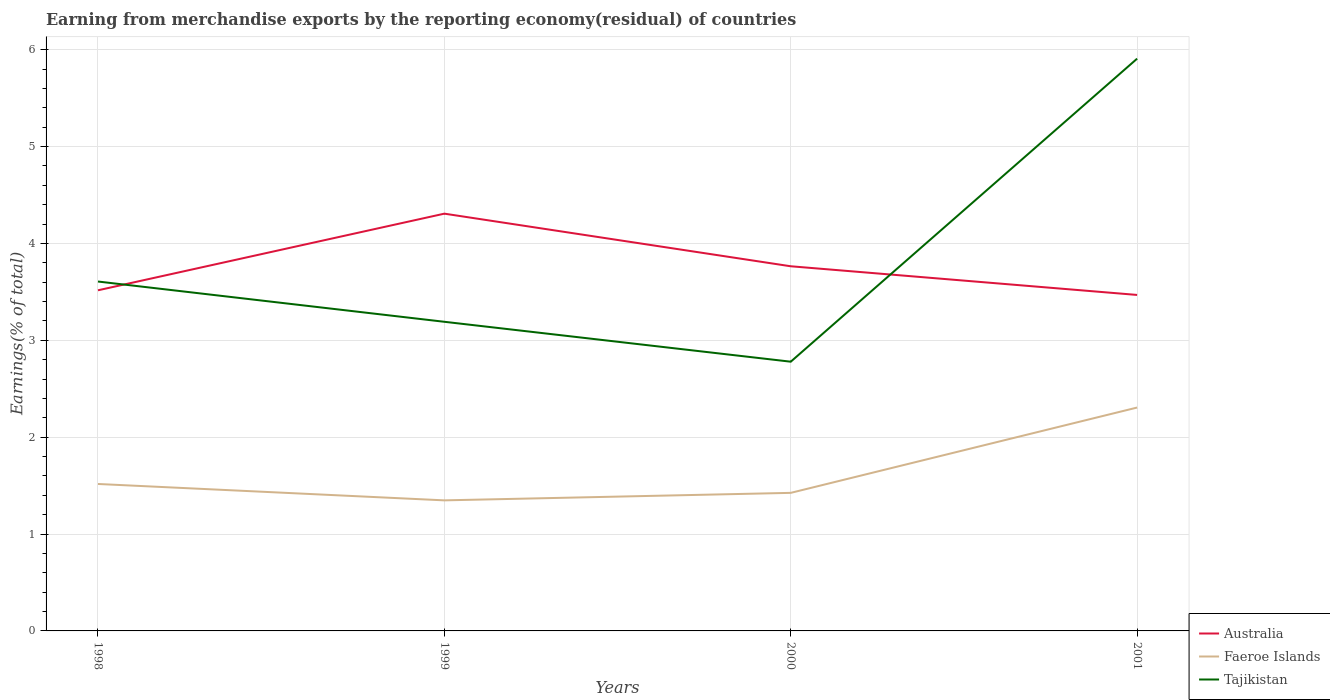Across all years, what is the maximum percentage of amount earned from merchandise exports in Faeroe Islands?
Make the answer very short. 1.35. In which year was the percentage of amount earned from merchandise exports in Faeroe Islands maximum?
Provide a short and direct response. 1999. What is the total percentage of amount earned from merchandise exports in Faeroe Islands in the graph?
Make the answer very short. -0.96. What is the difference between the highest and the second highest percentage of amount earned from merchandise exports in Faeroe Islands?
Make the answer very short. 0.96. What is the difference between the highest and the lowest percentage of amount earned from merchandise exports in Australia?
Make the answer very short. 2. Is the percentage of amount earned from merchandise exports in Australia strictly greater than the percentage of amount earned from merchandise exports in Faeroe Islands over the years?
Your response must be concise. No. How many years are there in the graph?
Your response must be concise. 4. What is the difference between two consecutive major ticks on the Y-axis?
Provide a short and direct response. 1. Does the graph contain any zero values?
Provide a short and direct response. No. Where does the legend appear in the graph?
Give a very brief answer. Bottom right. How many legend labels are there?
Keep it short and to the point. 3. What is the title of the graph?
Provide a succinct answer. Earning from merchandise exports by the reporting economy(residual) of countries. What is the label or title of the Y-axis?
Make the answer very short. Earnings(% of total). What is the Earnings(% of total) of Australia in 1998?
Provide a succinct answer. 3.52. What is the Earnings(% of total) of Faeroe Islands in 1998?
Keep it short and to the point. 1.52. What is the Earnings(% of total) of Tajikistan in 1998?
Your answer should be very brief. 3.61. What is the Earnings(% of total) of Australia in 1999?
Your answer should be very brief. 4.31. What is the Earnings(% of total) of Faeroe Islands in 1999?
Offer a terse response. 1.35. What is the Earnings(% of total) in Tajikistan in 1999?
Keep it short and to the point. 3.19. What is the Earnings(% of total) of Australia in 2000?
Give a very brief answer. 3.76. What is the Earnings(% of total) of Faeroe Islands in 2000?
Keep it short and to the point. 1.43. What is the Earnings(% of total) in Tajikistan in 2000?
Your answer should be very brief. 2.78. What is the Earnings(% of total) of Australia in 2001?
Offer a very short reply. 3.47. What is the Earnings(% of total) in Faeroe Islands in 2001?
Offer a terse response. 2.31. What is the Earnings(% of total) in Tajikistan in 2001?
Make the answer very short. 5.91. Across all years, what is the maximum Earnings(% of total) in Australia?
Your answer should be compact. 4.31. Across all years, what is the maximum Earnings(% of total) of Faeroe Islands?
Your answer should be compact. 2.31. Across all years, what is the maximum Earnings(% of total) of Tajikistan?
Give a very brief answer. 5.91. Across all years, what is the minimum Earnings(% of total) in Australia?
Your answer should be compact. 3.47. Across all years, what is the minimum Earnings(% of total) in Faeroe Islands?
Your answer should be very brief. 1.35. Across all years, what is the minimum Earnings(% of total) in Tajikistan?
Your answer should be compact. 2.78. What is the total Earnings(% of total) in Australia in the graph?
Provide a succinct answer. 15.06. What is the total Earnings(% of total) in Faeroe Islands in the graph?
Provide a succinct answer. 6.6. What is the total Earnings(% of total) of Tajikistan in the graph?
Keep it short and to the point. 15.48. What is the difference between the Earnings(% of total) of Australia in 1998 and that in 1999?
Provide a short and direct response. -0.79. What is the difference between the Earnings(% of total) in Faeroe Islands in 1998 and that in 1999?
Your answer should be compact. 0.17. What is the difference between the Earnings(% of total) of Tajikistan in 1998 and that in 1999?
Give a very brief answer. 0.42. What is the difference between the Earnings(% of total) of Australia in 1998 and that in 2000?
Keep it short and to the point. -0.25. What is the difference between the Earnings(% of total) in Faeroe Islands in 1998 and that in 2000?
Provide a succinct answer. 0.09. What is the difference between the Earnings(% of total) of Tajikistan in 1998 and that in 2000?
Give a very brief answer. 0.83. What is the difference between the Earnings(% of total) in Australia in 1998 and that in 2001?
Your answer should be very brief. 0.05. What is the difference between the Earnings(% of total) of Faeroe Islands in 1998 and that in 2001?
Ensure brevity in your answer.  -0.79. What is the difference between the Earnings(% of total) of Tajikistan in 1998 and that in 2001?
Make the answer very short. -2.3. What is the difference between the Earnings(% of total) of Australia in 1999 and that in 2000?
Your answer should be very brief. 0.54. What is the difference between the Earnings(% of total) in Faeroe Islands in 1999 and that in 2000?
Offer a terse response. -0.08. What is the difference between the Earnings(% of total) in Tajikistan in 1999 and that in 2000?
Your answer should be very brief. 0.41. What is the difference between the Earnings(% of total) in Australia in 1999 and that in 2001?
Make the answer very short. 0.84. What is the difference between the Earnings(% of total) in Faeroe Islands in 1999 and that in 2001?
Your answer should be very brief. -0.96. What is the difference between the Earnings(% of total) in Tajikistan in 1999 and that in 2001?
Give a very brief answer. -2.72. What is the difference between the Earnings(% of total) of Australia in 2000 and that in 2001?
Make the answer very short. 0.3. What is the difference between the Earnings(% of total) of Faeroe Islands in 2000 and that in 2001?
Offer a very short reply. -0.88. What is the difference between the Earnings(% of total) of Tajikistan in 2000 and that in 2001?
Provide a short and direct response. -3.13. What is the difference between the Earnings(% of total) of Australia in 1998 and the Earnings(% of total) of Faeroe Islands in 1999?
Your response must be concise. 2.17. What is the difference between the Earnings(% of total) in Australia in 1998 and the Earnings(% of total) in Tajikistan in 1999?
Your answer should be compact. 0.33. What is the difference between the Earnings(% of total) in Faeroe Islands in 1998 and the Earnings(% of total) in Tajikistan in 1999?
Make the answer very short. -1.67. What is the difference between the Earnings(% of total) in Australia in 1998 and the Earnings(% of total) in Faeroe Islands in 2000?
Your answer should be compact. 2.09. What is the difference between the Earnings(% of total) of Australia in 1998 and the Earnings(% of total) of Tajikistan in 2000?
Offer a terse response. 0.74. What is the difference between the Earnings(% of total) in Faeroe Islands in 1998 and the Earnings(% of total) in Tajikistan in 2000?
Your response must be concise. -1.26. What is the difference between the Earnings(% of total) of Australia in 1998 and the Earnings(% of total) of Faeroe Islands in 2001?
Provide a short and direct response. 1.21. What is the difference between the Earnings(% of total) of Australia in 1998 and the Earnings(% of total) of Tajikistan in 2001?
Provide a succinct answer. -2.39. What is the difference between the Earnings(% of total) of Faeroe Islands in 1998 and the Earnings(% of total) of Tajikistan in 2001?
Make the answer very short. -4.39. What is the difference between the Earnings(% of total) in Australia in 1999 and the Earnings(% of total) in Faeroe Islands in 2000?
Your answer should be very brief. 2.88. What is the difference between the Earnings(% of total) in Australia in 1999 and the Earnings(% of total) in Tajikistan in 2000?
Your answer should be compact. 1.53. What is the difference between the Earnings(% of total) in Faeroe Islands in 1999 and the Earnings(% of total) in Tajikistan in 2000?
Your answer should be very brief. -1.43. What is the difference between the Earnings(% of total) of Australia in 1999 and the Earnings(% of total) of Faeroe Islands in 2001?
Offer a very short reply. 2. What is the difference between the Earnings(% of total) of Australia in 1999 and the Earnings(% of total) of Tajikistan in 2001?
Provide a succinct answer. -1.6. What is the difference between the Earnings(% of total) in Faeroe Islands in 1999 and the Earnings(% of total) in Tajikistan in 2001?
Your answer should be very brief. -4.56. What is the difference between the Earnings(% of total) in Australia in 2000 and the Earnings(% of total) in Faeroe Islands in 2001?
Your answer should be compact. 1.46. What is the difference between the Earnings(% of total) of Australia in 2000 and the Earnings(% of total) of Tajikistan in 2001?
Provide a succinct answer. -2.14. What is the difference between the Earnings(% of total) in Faeroe Islands in 2000 and the Earnings(% of total) in Tajikistan in 2001?
Provide a succinct answer. -4.48. What is the average Earnings(% of total) in Australia per year?
Ensure brevity in your answer.  3.76. What is the average Earnings(% of total) of Faeroe Islands per year?
Make the answer very short. 1.65. What is the average Earnings(% of total) in Tajikistan per year?
Keep it short and to the point. 3.87. In the year 1998, what is the difference between the Earnings(% of total) in Australia and Earnings(% of total) in Faeroe Islands?
Your response must be concise. 2. In the year 1998, what is the difference between the Earnings(% of total) of Australia and Earnings(% of total) of Tajikistan?
Provide a succinct answer. -0.09. In the year 1998, what is the difference between the Earnings(% of total) in Faeroe Islands and Earnings(% of total) in Tajikistan?
Provide a succinct answer. -2.09. In the year 1999, what is the difference between the Earnings(% of total) of Australia and Earnings(% of total) of Faeroe Islands?
Your answer should be very brief. 2.96. In the year 1999, what is the difference between the Earnings(% of total) of Australia and Earnings(% of total) of Tajikistan?
Keep it short and to the point. 1.12. In the year 1999, what is the difference between the Earnings(% of total) in Faeroe Islands and Earnings(% of total) in Tajikistan?
Offer a terse response. -1.84. In the year 2000, what is the difference between the Earnings(% of total) of Australia and Earnings(% of total) of Faeroe Islands?
Keep it short and to the point. 2.34. In the year 2000, what is the difference between the Earnings(% of total) in Australia and Earnings(% of total) in Tajikistan?
Your answer should be compact. 0.99. In the year 2000, what is the difference between the Earnings(% of total) in Faeroe Islands and Earnings(% of total) in Tajikistan?
Offer a terse response. -1.35. In the year 2001, what is the difference between the Earnings(% of total) of Australia and Earnings(% of total) of Faeroe Islands?
Offer a very short reply. 1.16. In the year 2001, what is the difference between the Earnings(% of total) in Australia and Earnings(% of total) in Tajikistan?
Keep it short and to the point. -2.44. In the year 2001, what is the difference between the Earnings(% of total) in Faeroe Islands and Earnings(% of total) in Tajikistan?
Keep it short and to the point. -3.6. What is the ratio of the Earnings(% of total) of Australia in 1998 to that in 1999?
Make the answer very short. 0.82. What is the ratio of the Earnings(% of total) in Faeroe Islands in 1998 to that in 1999?
Give a very brief answer. 1.13. What is the ratio of the Earnings(% of total) in Tajikistan in 1998 to that in 1999?
Ensure brevity in your answer.  1.13. What is the ratio of the Earnings(% of total) in Australia in 1998 to that in 2000?
Give a very brief answer. 0.93. What is the ratio of the Earnings(% of total) of Faeroe Islands in 1998 to that in 2000?
Make the answer very short. 1.06. What is the ratio of the Earnings(% of total) of Tajikistan in 1998 to that in 2000?
Keep it short and to the point. 1.3. What is the ratio of the Earnings(% of total) of Australia in 1998 to that in 2001?
Your answer should be compact. 1.01. What is the ratio of the Earnings(% of total) of Faeroe Islands in 1998 to that in 2001?
Provide a succinct answer. 0.66. What is the ratio of the Earnings(% of total) in Tajikistan in 1998 to that in 2001?
Offer a terse response. 0.61. What is the ratio of the Earnings(% of total) in Australia in 1999 to that in 2000?
Your answer should be very brief. 1.14. What is the ratio of the Earnings(% of total) in Faeroe Islands in 1999 to that in 2000?
Offer a very short reply. 0.95. What is the ratio of the Earnings(% of total) in Tajikistan in 1999 to that in 2000?
Provide a short and direct response. 1.15. What is the ratio of the Earnings(% of total) in Australia in 1999 to that in 2001?
Make the answer very short. 1.24. What is the ratio of the Earnings(% of total) in Faeroe Islands in 1999 to that in 2001?
Your answer should be compact. 0.58. What is the ratio of the Earnings(% of total) in Tajikistan in 1999 to that in 2001?
Give a very brief answer. 0.54. What is the ratio of the Earnings(% of total) of Australia in 2000 to that in 2001?
Give a very brief answer. 1.09. What is the ratio of the Earnings(% of total) of Faeroe Islands in 2000 to that in 2001?
Your answer should be compact. 0.62. What is the ratio of the Earnings(% of total) in Tajikistan in 2000 to that in 2001?
Give a very brief answer. 0.47. What is the difference between the highest and the second highest Earnings(% of total) in Australia?
Make the answer very short. 0.54. What is the difference between the highest and the second highest Earnings(% of total) in Faeroe Islands?
Your answer should be compact. 0.79. What is the difference between the highest and the second highest Earnings(% of total) of Tajikistan?
Your answer should be very brief. 2.3. What is the difference between the highest and the lowest Earnings(% of total) of Australia?
Your answer should be compact. 0.84. What is the difference between the highest and the lowest Earnings(% of total) of Faeroe Islands?
Offer a terse response. 0.96. What is the difference between the highest and the lowest Earnings(% of total) of Tajikistan?
Your answer should be compact. 3.13. 